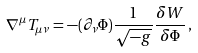<formula> <loc_0><loc_0><loc_500><loc_500>\nabla ^ { \mu } T _ { \mu \nu } = - ( \partial _ { \nu } \Phi ) \frac { 1 } { \sqrt { - g } } \frac { \delta W } { \delta \Phi } \, ,</formula> 